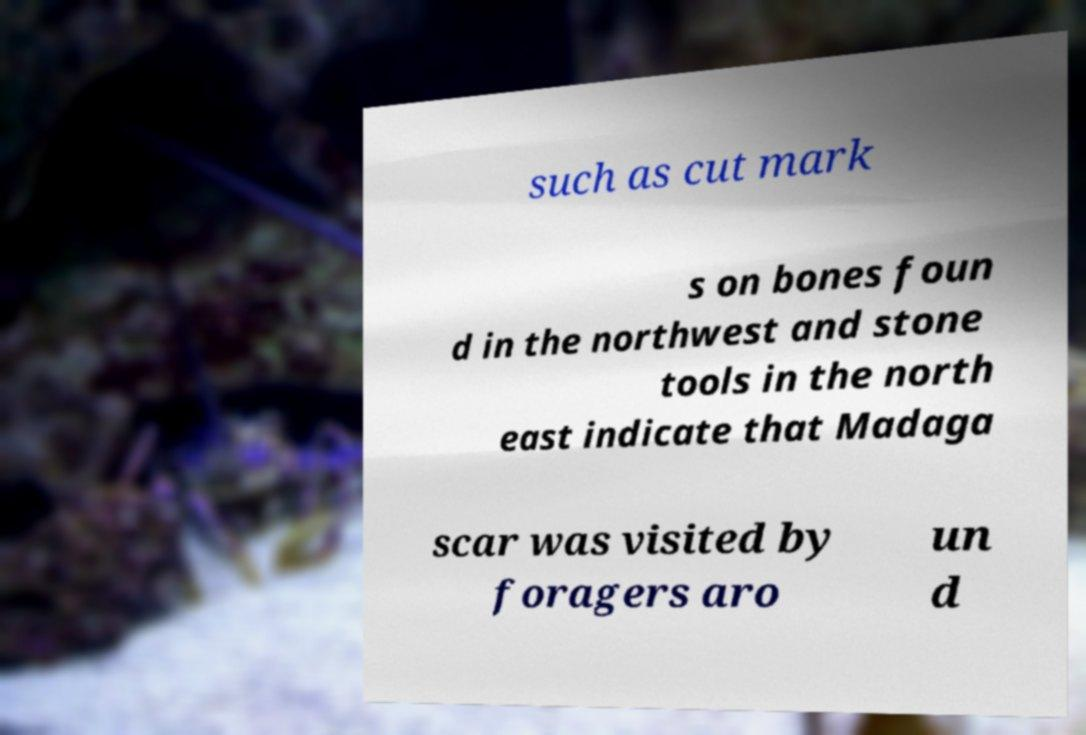Please read and relay the text visible in this image. What does it say? such as cut mark s on bones foun d in the northwest and stone tools in the north east indicate that Madaga scar was visited by foragers aro un d 